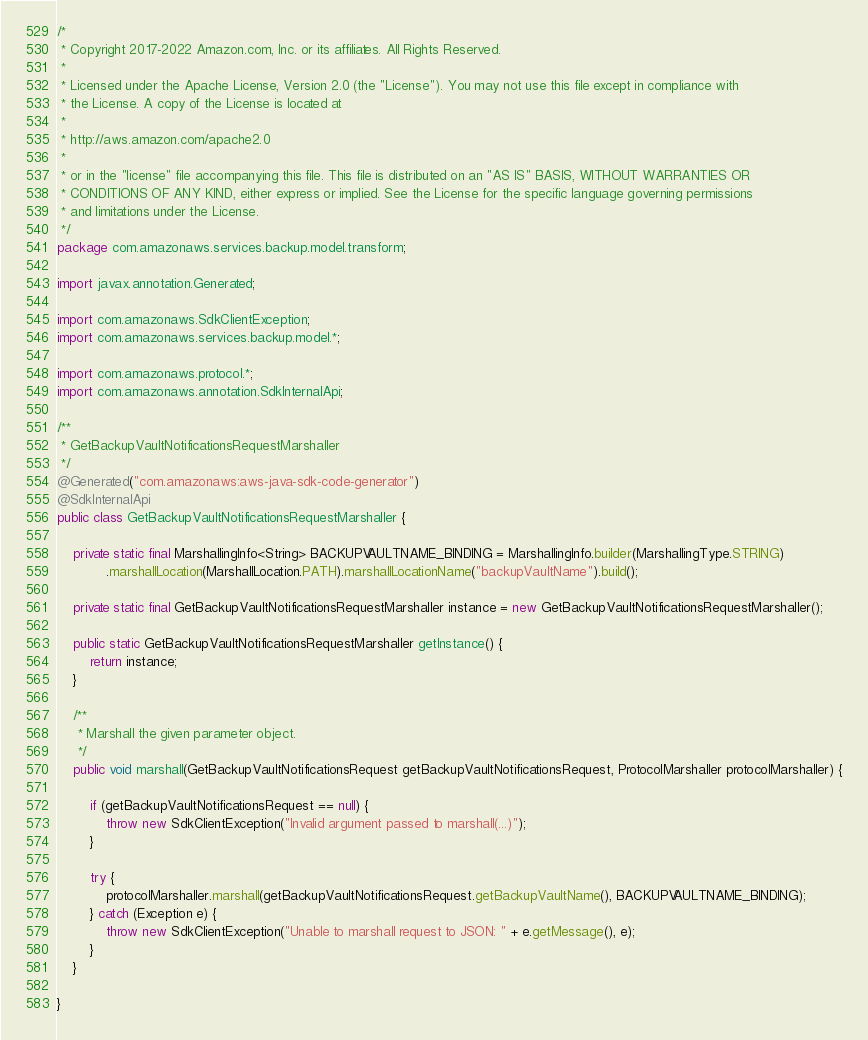<code> <loc_0><loc_0><loc_500><loc_500><_Java_>/*
 * Copyright 2017-2022 Amazon.com, Inc. or its affiliates. All Rights Reserved.
 * 
 * Licensed under the Apache License, Version 2.0 (the "License"). You may not use this file except in compliance with
 * the License. A copy of the License is located at
 * 
 * http://aws.amazon.com/apache2.0
 * 
 * or in the "license" file accompanying this file. This file is distributed on an "AS IS" BASIS, WITHOUT WARRANTIES OR
 * CONDITIONS OF ANY KIND, either express or implied. See the License for the specific language governing permissions
 * and limitations under the License.
 */
package com.amazonaws.services.backup.model.transform;

import javax.annotation.Generated;

import com.amazonaws.SdkClientException;
import com.amazonaws.services.backup.model.*;

import com.amazonaws.protocol.*;
import com.amazonaws.annotation.SdkInternalApi;

/**
 * GetBackupVaultNotificationsRequestMarshaller
 */
@Generated("com.amazonaws:aws-java-sdk-code-generator")
@SdkInternalApi
public class GetBackupVaultNotificationsRequestMarshaller {

    private static final MarshallingInfo<String> BACKUPVAULTNAME_BINDING = MarshallingInfo.builder(MarshallingType.STRING)
            .marshallLocation(MarshallLocation.PATH).marshallLocationName("backupVaultName").build();

    private static final GetBackupVaultNotificationsRequestMarshaller instance = new GetBackupVaultNotificationsRequestMarshaller();

    public static GetBackupVaultNotificationsRequestMarshaller getInstance() {
        return instance;
    }

    /**
     * Marshall the given parameter object.
     */
    public void marshall(GetBackupVaultNotificationsRequest getBackupVaultNotificationsRequest, ProtocolMarshaller protocolMarshaller) {

        if (getBackupVaultNotificationsRequest == null) {
            throw new SdkClientException("Invalid argument passed to marshall(...)");
        }

        try {
            protocolMarshaller.marshall(getBackupVaultNotificationsRequest.getBackupVaultName(), BACKUPVAULTNAME_BINDING);
        } catch (Exception e) {
            throw new SdkClientException("Unable to marshall request to JSON: " + e.getMessage(), e);
        }
    }

}
</code> 